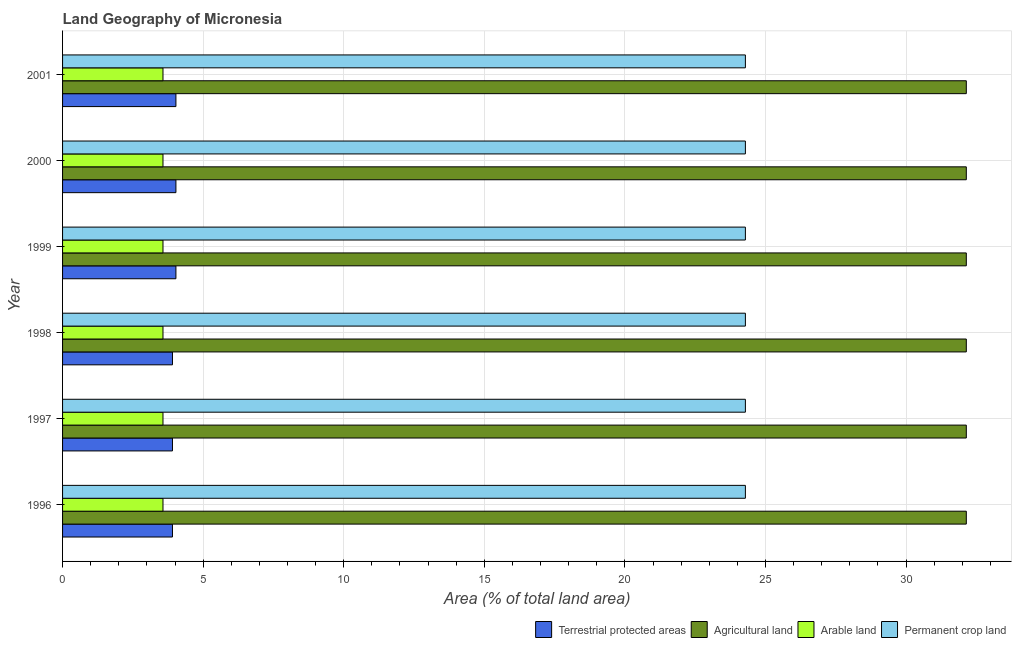How many groups of bars are there?
Ensure brevity in your answer.  6. Are the number of bars per tick equal to the number of legend labels?
Provide a short and direct response. Yes. What is the percentage of land under terrestrial protection in 1998?
Provide a succinct answer. 3.91. Across all years, what is the maximum percentage of area under agricultural land?
Give a very brief answer. 32.14. Across all years, what is the minimum percentage of area under permanent crop land?
Your answer should be compact. 24.29. In which year was the percentage of area under permanent crop land maximum?
Your answer should be very brief. 1996. In which year was the percentage of area under arable land minimum?
Your answer should be very brief. 1996. What is the total percentage of land under terrestrial protection in the graph?
Offer a terse response. 23.82. What is the difference between the percentage of area under arable land in 1997 and the percentage of area under agricultural land in 2001?
Your response must be concise. -28.57. What is the average percentage of area under agricultural land per year?
Your answer should be compact. 32.14. In the year 1999, what is the difference between the percentage of land under terrestrial protection and percentage of area under permanent crop land?
Provide a succinct answer. -20.25. In how many years, is the percentage of area under permanent crop land greater than 7 %?
Your answer should be very brief. 6. What is the ratio of the percentage of area under arable land in 1997 to that in 2000?
Make the answer very short. 1. Is the percentage of area under arable land in 1996 less than that in 1997?
Your answer should be very brief. No. What is the difference between the highest and the second highest percentage of area under arable land?
Give a very brief answer. 0. What is the difference between the highest and the lowest percentage of area under agricultural land?
Offer a terse response. 0. In how many years, is the percentage of land under terrestrial protection greater than the average percentage of land under terrestrial protection taken over all years?
Provide a succinct answer. 3. Is the sum of the percentage of land under terrestrial protection in 1997 and 2001 greater than the maximum percentage of area under permanent crop land across all years?
Ensure brevity in your answer.  No. What does the 1st bar from the top in 1998 represents?
Your answer should be compact. Permanent crop land. What does the 4th bar from the bottom in 1998 represents?
Offer a very short reply. Permanent crop land. Does the graph contain any zero values?
Ensure brevity in your answer.  No. Does the graph contain grids?
Offer a very short reply. Yes. Where does the legend appear in the graph?
Give a very brief answer. Bottom right. How many legend labels are there?
Make the answer very short. 4. How are the legend labels stacked?
Ensure brevity in your answer.  Horizontal. What is the title of the graph?
Make the answer very short. Land Geography of Micronesia. What is the label or title of the X-axis?
Give a very brief answer. Area (% of total land area). What is the Area (% of total land area) in Terrestrial protected areas in 1996?
Your answer should be compact. 3.91. What is the Area (% of total land area) in Agricultural land in 1996?
Give a very brief answer. 32.14. What is the Area (% of total land area) of Arable land in 1996?
Provide a short and direct response. 3.57. What is the Area (% of total land area) of Permanent crop land in 1996?
Ensure brevity in your answer.  24.29. What is the Area (% of total land area) of Terrestrial protected areas in 1997?
Provide a short and direct response. 3.91. What is the Area (% of total land area) of Agricultural land in 1997?
Offer a terse response. 32.14. What is the Area (% of total land area) of Arable land in 1997?
Keep it short and to the point. 3.57. What is the Area (% of total land area) of Permanent crop land in 1997?
Ensure brevity in your answer.  24.29. What is the Area (% of total land area) of Terrestrial protected areas in 1998?
Offer a terse response. 3.91. What is the Area (% of total land area) of Agricultural land in 1998?
Your answer should be compact. 32.14. What is the Area (% of total land area) of Arable land in 1998?
Your response must be concise. 3.57. What is the Area (% of total land area) of Permanent crop land in 1998?
Provide a succinct answer. 24.29. What is the Area (% of total land area) of Terrestrial protected areas in 1999?
Provide a succinct answer. 4.03. What is the Area (% of total land area) of Agricultural land in 1999?
Your answer should be compact. 32.14. What is the Area (% of total land area) of Arable land in 1999?
Keep it short and to the point. 3.57. What is the Area (% of total land area) in Permanent crop land in 1999?
Offer a very short reply. 24.29. What is the Area (% of total land area) in Terrestrial protected areas in 2000?
Keep it short and to the point. 4.03. What is the Area (% of total land area) of Agricultural land in 2000?
Offer a terse response. 32.14. What is the Area (% of total land area) of Arable land in 2000?
Give a very brief answer. 3.57. What is the Area (% of total land area) of Permanent crop land in 2000?
Offer a terse response. 24.29. What is the Area (% of total land area) of Terrestrial protected areas in 2001?
Your answer should be very brief. 4.03. What is the Area (% of total land area) of Agricultural land in 2001?
Give a very brief answer. 32.14. What is the Area (% of total land area) in Arable land in 2001?
Your answer should be very brief. 3.57. What is the Area (% of total land area) of Permanent crop land in 2001?
Offer a very short reply. 24.29. Across all years, what is the maximum Area (% of total land area) of Terrestrial protected areas?
Ensure brevity in your answer.  4.03. Across all years, what is the maximum Area (% of total land area) of Agricultural land?
Make the answer very short. 32.14. Across all years, what is the maximum Area (% of total land area) of Arable land?
Provide a short and direct response. 3.57. Across all years, what is the maximum Area (% of total land area) of Permanent crop land?
Your answer should be compact. 24.29. Across all years, what is the minimum Area (% of total land area) of Terrestrial protected areas?
Keep it short and to the point. 3.91. Across all years, what is the minimum Area (% of total land area) of Agricultural land?
Make the answer very short. 32.14. Across all years, what is the minimum Area (% of total land area) in Arable land?
Provide a short and direct response. 3.57. Across all years, what is the minimum Area (% of total land area) in Permanent crop land?
Provide a short and direct response. 24.29. What is the total Area (% of total land area) in Terrestrial protected areas in the graph?
Your response must be concise. 23.82. What is the total Area (% of total land area) in Agricultural land in the graph?
Your answer should be very brief. 192.86. What is the total Area (% of total land area) in Arable land in the graph?
Give a very brief answer. 21.43. What is the total Area (% of total land area) of Permanent crop land in the graph?
Keep it short and to the point. 145.71. What is the difference between the Area (% of total land area) of Agricultural land in 1996 and that in 1997?
Make the answer very short. 0. What is the difference between the Area (% of total land area) of Permanent crop land in 1996 and that in 1997?
Your response must be concise. 0. What is the difference between the Area (% of total land area) in Terrestrial protected areas in 1996 and that in 1998?
Give a very brief answer. 0. What is the difference between the Area (% of total land area) of Terrestrial protected areas in 1996 and that in 1999?
Ensure brevity in your answer.  -0.12. What is the difference between the Area (% of total land area) in Agricultural land in 1996 and that in 1999?
Provide a succinct answer. 0. What is the difference between the Area (% of total land area) of Arable land in 1996 and that in 1999?
Provide a succinct answer. 0. What is the difference between the Area (% of total land area) in Permanent crop land in 1996 and that in 1999?
Ensure brevity in your answer.  0. What is the difference between the Area (% of total land area) in Terrestrial protected areas in 1996 and that in 2000?
Offer a very short reply. -0.12. What is the difference between the Area (% of total land area) in Agricultural land in 1996 and that in 2000?
Your answer should be compact. 0. What is the difference between the Area (% of total land area) of Arable land in 1996 and that in 2000?
Keep it short and to the point. 0. What is the difference between the Area (% of total land area) in Terrestrial protected areas in 1996 and that in 2001?
Your answer should be compact. -0.12. What is the difference between the Area (% of total land area) of Permanent crop land in 1996 and that in 2001?
Your answer should be very brief. 0. What is the difference between the Area (% of total land area) in Terrestrial protected areas in 1997 and that in 1998?
Offer a terse response. 0. What is the difference between the Area (% of total land area) in Agricultural land in 1997 and that in 1998?
Offer a very short reply. 0. What is the difference between the Area (% of total land area) in Arable land in 1997 and that in 1998?
Your answer should be compact. 0. What is the difference between the Area (% of total land area) in Permanent crop land in 1997 and that in 1998?
Provide a succinct answer. 0. What is the difference between the Area (% of total land area) in Terrestrial protected areas in 1997 and that in 1999?
Your response must be concise. -0.12. What is the difference between the Area (% of total land area) in Arable land in 1997 and that in 1999?
Provide a succinct answer. 0. What is the difference between the Area (% of total land area) in Terrestrial protected areas in 1997 and that in 2000?
Offer a terse response. -0.12. What is the difference between the Area (% of total land area) in Agricultural land in 1997 and that in 2000?
Your answer should be very brief. 0. What is the difference between the Area (% of total land area) of Permanent crop land in 1997 and that in 2000?
Give a very brief answer. 0. What is the difference between the Area (% of total land area) of Terrestrial protected areas in 1997 and that in 2001?
Give a very brief answer. -0.12. What is the difference between the Area (% of total land area) in Arable land in 1997 and that in 2001?
Give a very brief answer. 0. What is the difference between the Area (% of total land area) of Permanent crop land in 1997 and that in 2001?
Make the answer very short. 0. What is the difference between the Area (% of total land area) of Terrestrial protected areas in 1998 and that in 1999?
Your response must be concise. -0.12. What is the difference between the Area (% of total land area) of Arable land in 1998 and that in 1999?
Your response must be concise. 0. What is the difference between the Area (% of total land area) of Permanent crop land in 1998 and that in 1999?
Offer a terse response. 0. What is the difference between the Area (% of total land area) of Terrestrial protected areas in 1998 and that in 2000?
Keep it short and to the point. -0.12. What is the difference between the Area (% of total land area) of Agricultural land in 1998 and that in 2000?
Give a very brief answer. 0. What is the difference between the Area (% of total land area) of Arable land in 1998 and that in 2000?
Your answer should be compact. 0. What is the difference between the Area (% of total land area) in Permanent crop land in 1998 and that in 2000?
Your answer should be very brief. 0. What is the difference between the Area (% of total land area) of Terrestrial protected areas in 1998 and that in 2001?
Your answer should be compact. -0.12. What is the difference between the Area (% of total land area) of Agricultural land in 1998 and that in 2001?
Your answer should be very brief. 0. What is the difference between the Area (% of total land area) in Terrestrial protected areas in 1999 and that in 2000?
Keep it short and to the point. 0. What is the difference between the Area (% of total land area) of Permanent crop land in 1999 and that in 2000?
Your answer should be very brief. 0. What is the difference between the Area (% of total land area) in Permanent crop land in 1999 and that in 2001?
Ensure brevity in your answer.  0. What is the difference between the Area (% of total land area) in Terrestrial protected areas in 2000 and that in 2001?
Provide a succinct answer. -0. What is the difference between the Area (% of total land area) in Arable land in 2000 and that in 2001?
Provide a short and direct response. 0. What is the difference between the Area (% of total land area) of Terrestrial protected areas in 1996 and the Area (% of total land area) of Agricultural land in 1997?
Give a very brief answer. -28.23. What is the difference between the Area (% of total land area) in Terrestrial protected areas in 1996 and the Area (% of total land area) in Arable land in 1997?
Ensure brevity in your answer.  0.34. What is the difference between the Area (% of total land area) in Terrestrial protected areas in 1996 and the Area (% of total land area) in Permanent crop land in 1997?
Provide a short and direct response. -20.38. What is the difference between the Area (% of total land area) in Agricultural land in 1996 and the Area (% of total land area) in Arable land in 1997?
Provide a short and direct response. 28.57. What is the difference between the Area (% of total land area) of Agricultural land in 1996 and the Area (% of total land area) of Permanent crop land in 1997?
Your response must be concise. 7.86. What is the difference between the Area (% of total land area) in Arable land in 1996 and the Area (% of total land area) in Permanent crop land in 1997?
Your answer should be very brief. -20.71. What is the difference between the Area (% of total land area) in Terrestrial protected areas in 1996 and the Area (% of total land area) in Agricultural land in 1998?
Offer a very short reply. -28.23. What is the difference between the Area (% of total land area) of Terrestrial protected areas in 1996 and the Area (% of total land area) of Arable land in 1998?
Keep it short and to the point. 0.34. What is the difference between the Area (% of total land area) of Terrestrial protected areas in 1996 and the Area (% of total land area) of Permanent crop land in 1998?
Make the answer very short. -20.38. What is the difference between the Area (% of total land area) in Agricultural land in 1996 and the Area (% of total land area) in Arable land in 1998?
Keep it short and to the point. 28.57. What is the difference between the Area (% of total land area) of Agricultural land in 1996 and the Area (% of total land area) of Permanent crop land in 1998?
Ensure brevity in your answer.  7.86. What is the difference between the Area (% of total land area) in Arable land in 1996 and the Area (% of total land area) in Permanent crop land in 1998?
Provide a succinct answer. -20.71. What is the difference between the Area (% of total land area) in Terrestrial protected areas in 1996 and the Area (% of total land area) in Agricultural land in 1999?
Keep it short and to the point. -28.23. What is the difference between the Area (% of total land area) of Terrestrial protected areas in 1996 and the Area (% of total land area) of Arable land in 1999?
Provide a short and direct response. 0.34. What is the difference between the Area (% of total land area) in Terrestrial protected areas in 1996 and the Area (% of total land area) in Permanent crop land in 1999?
Provide a short and direct response. -20.38. What is the difference between the Area (% of total land area) in Agricultural land in 1996 and the Area (% of total land area) in Arable land in 1999?
Provide a succinct answer. 28.57. What is the difference between the Area (% of total land area) of Agricultural land in 1996 and the Area (% of total land area) of Permanent crop land in 1999?
Your answer should be compact. 7.86. What is the difference between the Area (% of total land area) of Arable land in 1996 and the Area (% of total land area) of Permanent crop land in 1999?
Give a very brief answer. -20.71. What is the difference between the Area (% of total land area) in Terrestrial protected areas in 1996 and the Area (% of total land area) in Agricultural land in 2000?
Provide a succinct answer. -28.23. What is the difference between the Area (% of total land area) of Terrestrial protected areas in 1996 and the Area (% of total land area) of Arable land in 2000?
Your answer should be very brief. 0.34. What is the difference between the Area (% of total land area) in Terrestrial protected areas in 1996 and the Area (% of total land area) in Permanent crop land in 2000?
Offer a very short reply. -20.38. What is the difference between the Area (% of total land area) in Agricultural land in 1996 and the Area (% of total land area) in Arable land in 2000?
Keep it short and to the point. 28.57. What is the difference between the Area (% of total land area) in Agricultural land in 1996 and the Area (% of total land area) in Permanent crop land in 2000?
Your answer should be compact. 7.86. What is the difference between the Area (% of total land area) of Arable land in 1996 and the Area (% of total land area) of Permanent crop land in 2000?
Keep it short and to the point. -20.71. What is the difference between the Area (% of total land area) in Terrestrial protected areas in 1996 and the Area (% of total land area) in Agricultural land in 2001?
Your response must be concise. -28.23. What is the difference between the Area (% of total land area) in Terrestrial protected areas in 1996 and the Area (% of total land area) in Arable land in 2001?
Your answer should be very brief. 0.34. What is the difference between the Area (% of total land area) of Terrestrial protected areas in 1996 and the Area (% of total land area) of Permanent crop land in 2001?
Your answer should be very brief. -20.38. What is the difference between the Area (% of total land area) in Agricultural land in 1996 and the Area (% of total land area) in Arable land in 2001?
Your response must be concise. 28.57. What is the difference between the Area (% of total land area) in Agricultural land in 1996 and the Area (% of total land area) in Permanent crop land in 2001?
Give a very brief answer. 7.86. What is the difference between the Area (% of total land area) of Arable land in 1996 and the Area (% of total land area) of Permanent crop land in 2001?
Your response must be concise. -20.71. What is the difference between the Area (% of total land area) in Terrestrial protected areas in 1997 and the Area (% of total land area) in Agricultural land in 1998?
Provide a succinct answer. -28.23. What is the difference between the Area (% of total land area) of Terrestrial protected areas in 1997 and the Area (% of total land area) of Arable land in 1998?
Your answer should be compact. 0.34. What is the difference between the Area (% of total land area) in Terrestrial protected areas in 1997 and the Area (% of total land area) in Permanent crop land in 1998?
Keep it short and to the point. -20.38. What is the difference between the Area (% of total land area) of Agricultural land in 1997 and the Area (% of total land area) of Arable land in 1998?
Keep it short and to the point. 28.57. What is the difference between the Area (% of total land area) in Agricultural land in 1997 and the Area (% of total land area) in Permanent crop land in 1998?
Provide a succinct answer. 7.86. What is the difference between the Area (% of total land area) in Arable land in 1997 and the Area (% of total land area) in Permanent crop land in 1998?
Provide a short and direct response. -20.71. What is the difference between the Area (% of total land area) in Terrestrial protected areas in 1997 and the Area (% of total land area) in Agricultural land in 1999?
Ensure brevity in your answer.  -28.23. What is the difference between the Area (% of total land area) in Terrestrial protected areas in 1997 and the Area (% of total land area) in Arable land in 1999?
Offer a terse response. 0.34. What is the difference between the Area (% of total land area) of Terrestrial protected areas in 1997 and the Area (% of total land area) of Permanent crop land in 1999?
Provide a succinct answer. -20.38. What is the difference between the Area (% of total land area) of Agricultural land in 1997 and the Area (% of total land area) of Arable land in 1999?
Give a very brief answer. 28.57. What is the difference between the Area (% of total land area) in Agricultural land in 1997 and the Area (% of total land area) in Permanent crop land in 1999?
Your answer should be very brief. 7.86. What is the difference between the Area (% of total land area) in Arable land in 1997 and the Area (% of total land area) in Permanent crop land in 1999?
Keep it short and to the point. -20.71. What is the difference between the Area (% of total land area) of Terrestrial protected areas in 1997 and the Area (% of total land area) of Agricultural land in 2000?
Provide a succinct answer. -28.23. What is the difference between the Area (% of total land area) of Terrestrial protected areas in 1997 and the Area (% of total land area) of Arable land in 2000?
Your response must be concise. 0.34. What is the difference between the Area (% of total land area) of Terrestrial protected areas in 1997 and the Area (% of total land area) of Permanent crop land in 2000?
Your answer should be compact. -20.38. What is the difference between the Area (% of total land area) of Agricultural land in 1997 and the Area (% of total land area) of Arable land in 2000?
Your answer should be very brief. 28.57. What is the difference between the Area (% of total land area) in Agricultural land in 1997 and the Area (% of total land area) in Permanent crop land in 2000?
Provide a short and direct response. 7.86. What is the difference between the Area (% of total land area) of Arable land in 1997 and the Area (% of total land area) of Permanent crop land in 2000?
Ensure brevity in your answer.  -20.71. What is the difference between the Area (% of total land area) in Terrestrial protected areas in 1997 and the Area (% of total land area) in Agricultural land in 2001?
Offer a terse response. -28.23. What is the difference between the Area (% of total land area) in Terrestrial protected areas in 1997 and the Area (% of total land area) in Arable land in 2001?
Your answer should be very brief. 0.34. What is the difference between the Area (% of total land area) of Terrestrial protected areas in 1997 and the Area (% of total land area) of Permanent crop land in 2001?
Offer a terse response. -20.38. What is the difference between the Area (% of total land area) in Agricultural land in 1997 and the Area (% of total land area) in Arable land in 2001?
Give a very brief answer. 28.57. What is the difference between the Area (% of total land area) in Agricultural land in 1997 and the Area (% of total land area) in Permanent crop land in 2001?
Provide a short and direct response. 7.86. What is the difference between the Area (% of total land area) in Arable land in 1997 and the Area (% of total land area) in Permanent crop land in 2001?
Keep it short and to the point. -20.71. What is the difference between the Area (% of total land area) in Terrestrial protected areas in 1998 and the Area (% of total land area) in Agricultural land in 1999?
Your answer should be very brief. -28.23. What is the difference between the Area (% of total land area) in Terrestrial protected areas in 1998 and the Area (% of total land area) in Arable land in 1999?
Your response must be concise. 0.34. What is the difference between the Area (% of total land area) of Terrestrial protected areas in 1998 and the Area (% of total land area) of Permanent crop land in 1999?
Offer a terse response. -20.38. What is the difference between the Area (% of total land area) in Agricultural land in 1998 and the Area (% of total land area) in Arable land in 1999?
Keep it short and to the point. 28.57. What is the difference between the Area (% of total land area) of Agricultural land in 1998 and the Area (% of total land area) of Permanent crop land in 1999?
Give a very brief answer. 7.86. What is the difference between the Area (% of total land area) of Arable land in 1998 and the Area (% of total land area) of Permanent crop land in 1999?
Your answer should be very brief. -20.71. What is the difference between the Area (% of total land area) of Terrestrial protected areas in 1998 and the Area (% of total land area) of Agricultural land in 2000?
Offer a terse response. -28.23. What is the difference between the Area (% of total land area) of Terrestrial protected areas in 1998 and the Area (% of total land area) of Arable land in 2000?
Offer a terse response. 0.34. What is the difference between the Area (% of total land area) in Terrestrial protected areas in 1998 and the Area (% of total land area) in Permanent crop land in 2000?
Offer a very short reply. -20.38. What is the difference between the Area (% of total land area) in Agricultural land in 1998 and the Area (% of total land area) in Arable land in 2000?
Offer a terse response. 28.57. What is the difference between the Area (% of total land area) of Agricultural land in 1998 and the Area (% of total land area) of Permanent crop land in 2000?
Ensure brevity in your answer.  7.86. What is the difference between the Area (% of total land area) of Arable land in 1998 and the Area (% of total land area) of Permanent crop land in 2000?
Keep it short and to the point. -20.71. What is the difference between the Area (% of total land area) of Terrestrial protected areas in 1998 and the Area (% of total land area) of Agricultural land in 2001?
Make the answer very short. -28.23. What is the difference between the Area (% of total land area) of Terrestrial protected areas in 1998 and the Area (% of total land area) of Arable land in 2001?
Give a very brief answer. 0.34. What is the difference between the Area (% of total land area) in Terrestrial protected areas in 1998 and the Area (% of total land area) in Permanent crop land in 2001?
Provide a short and direct response. -20.38. What is the difference between the Area (% of total land area) in Agricultural land in 1998 and the Area (% of total land area) in Arable land in 2001?
Offer a very short reply. 28.57. What is the difference between the Area (% of total land area) in Agricultural land in 1998 and the Area (% of total land area) in Permanent crop land in 2001?
Offer a terse response. 7.86. What is the difference between the Area (% of total land area) in Arable land in 1998 and the Area (% of total land area) in Permanent crop land in 2001?
Ensure brevity in your answer.  -20.71. What is the difference between the Area (% of total land area) in Terrestrial protected areas in 1999 and the Area (% of total land area) in Agricultural land in 2000?
Your response must be concise. -28.11. What is the difference between the Area (% of total land area) in Terrestrial protected areas in 1999 and the Area (% of total land area) in Arable land in 2000?
Keep it short and to the point. 0.46. What is the difference between the Area (% of total land area) in Terrestrial protected areas in 1999 and the Area (% of total land area) in Permanent crop land in 2000?
Offer a terse response. -20.25. What is the difference between the Area (% of total land area) in Agricultural land in 1999 and the Area (% of total land area) in Arable land in 2000?
Offer a very short reply. 28.57. What is the difference between the Area (% of total land area) in Agricultural land in 1999 and the Area (% of total land area) in Permanent crop land in 2000?
Provide a short and direct response. 7.86. What is the difference between the Area (% of total land area) of Arable land in 1999 and the Area (% of total land area) of Permanent crop land in 2000?
Provide a succinct answer. -20.71. What is the difference between the Area (% of total land area) of Terrestrial protected areas in 1999 and the Area (% of total land area) of Agricultural land in 2001?
Offer a terse response. -28.11. What is the difference between the Area (% of total land area) of Terrestrial protected areas in 1999 and the Area (% of total land area) of Arable land in 2001?
Your answer should be compact. 0.46. What is the difference between the Area (% of total land area) in Terrestrial protected areas in 1999 and the Area (% of total land area) in Permanent crop land in 2001?
Your answer should be very brief. -20.25. What is the difference between the Area (% of total land area) in Agricultural land in 1999 and the Area (% of total land area) in Arable land in 2001?
Provide a short and direct response. 28.57. What is the difference between the Area (% of total land area) of Agricultural land in 1999 and the Area (% of total land area) of Permanent crop land in 2001?
Offer a terse response. 7.86. What is the difference between the Area (% of total land area) of Arable land in 1999 and the Area (% of total land area) of Permanent crop land in 2001?
Keep it short and to the point. -20.71. What is the difference between the Area (% of total land area) in Terrestrial protected areas in 2000 and the Area (% of total land area) in Agricultural land in 2001?
Provide a succinct answer. -28.11. What is the difference between the Area (% of total land area) of Terrestrial protected areas in 2000 and the Area (% of total land area) of Arable land in 2001?
Make the answer very short. 0.46. What is the difference between the Area (% of total land area) in Terrestrial protected areas in 2000 and the Area (% of total land area) in Permanent crop land in 2001?
Give a very brief answer. -20.25. What is the difference between the Area (% of total land area) of Agricultural land in 2000 and the Area (% of total land area) of Arable land in 2001?
Ensure brevity in your answer.  28.57. What is the difference between the Area (% of total land area) in Agricultural land in 2000 and the Area (% of total land area) in Permanent crop land in 2001?
Ensure brevity in your answer.  7.86. What is the difference between the Area (% of total land area) of Arable land in 2000 and the Area (% of total land area) of Permanent crop land in 2001?
Make the answer very short. -20.71. What is the average Area (% of total land area) of Terrestrial protected areas per year?
Provide a succinct answer. 3.97. What is the average Area (% of total land area) of Agricultural land per year?
Your answer should be compact. 32.14. What is the average Area (% of total land area) in Arable land per year?
Your response must be concise. 3.57. What is the average Area (% of total land area) of Permanent crop land per year?
Offer a very short reply. 24.29. In the year 1996, what is the difference between the Area (% of total land area) in Terrestrial protected areas and Area (% of total land area) in Agricultural land?
Your response must be concise. -28.23. In the year 1996, what is the difference between the Area (% of total land area) in Terrestrial protected areas and Area (% of total land area) in Arable land?
Your answer should be very brief. 0.34. In the year 1996, what is the difference between the Area (% of total land area) of Terrestrial protected areas and Area (% of total land area) of Permanent crop land?
Keep it short and to the point. -20.38. In the year 1996, what is the difference between the Area (% of total land area) of Agricultural land and Area (% of total land area) of Arable land?
Your answer should be compact. 28.57. In the year 1996, what is the difference between the Area (% of total land area) of Agricultural land and Area (% of total land area) of Permanent crop land?
Provide a short and direct response. 7.86. In the year 1996, what is the difference between the Area (% of total land area) of Arable land and Area (% of total land area) of Permanent crop land?
Offer a terse response. -20.71. In the year 1997, what is the difference between the Area (% of total land area) in Terrestrial protected areas and Area (% of total land area) in Agricultural land?
Keep it short and to the point. -28.23. In the year 1997, what is the difference between the Area (% of total land area) of Terrestrial protected areas and Area (% of total land area) of Arable land?
Ensure brevity in your answer.  0.34. In the year 1997, what is the difference between the Area (% of total land area) in Terrestrial protected areas and Area (% of total land area) in Permanent crop land?
Your response must be concise. -20.38. In the year 1997, what is the difference between the Area (% of total land area) of Agricultural land and Area (% of total land area) of Arable land?
Your answer should be very brief. 28.57. In the year 1997, what is the difference between the Area (% of total land area) of Agricultural land and Area (% of total land area) of Permanent crop land?
Keep it short and to the point. 7.86. In the year 1997, what is the difference between the Area (% of total land area) in Arable land and Area (% of total land area) in Permanent crop land?
Give a very brief answer. -20.71. In the year 1998, what is the difference between the Area (% of total land area) of Terrestrial protected areas and Area (% of total land area) of Agricultural land?
Your answer should be very brief. -28.23. In the year 1998, what is the difference between the Area (% of total land area) in Terrestrial protected areas and Area (% of total land area) in Arable land?
Provide a short and direct response. 0.34. In the year 1998, what is the difference between the Area (% of total land area) of Terrestrial protected areas and Area (% of total land area) of Permanent crop land?
Give a very brief answer. -20.38. In the year 1998, what is the difference between the Area (% of total land area) in Agricultural land and Area (% of total land area) in Arable land?
Your answer should be very brief. 28.57. In the year 1998, what is the difference between the Area (% of total land area) of Agricultural land and Area (% of total land area) of Permanent crop land?
Your answer should be compact. 7.86. In the year 1998, what is the difference between the Area (% of total land area) of Arable land and Area (% of total land area) of Permanent crop land?
Keep it short and to the point. -20.71. In the year 1999, what is the difference between the Area (% of total land area) in Terrestrial protected areas and Area (% of total land area) in Agricultural land?
Ensure brevity in your answer.  -28.11. In the year 1999, what is the difference between the Area (% of total land area) in Terrestrial protected areas and Area (% of total land area) in Arable land?
Offer a very short reply. 0.46. In the year 1999, what is the difference between the Area (% of total land area) of Terrestrial protected areas and Area (% of total land area) of Permanent crop land?
Give a very brief answer. -20.25. In the year 1999, what is the difference between the Area (% of total land area) of Agricultural land and Area (% of total land area) of Arable land?
Ensure brevity in your answer.  28.57. In the year 1999, what is the difference between the Area (% of total land area) in Agricultural land and Area (% of total land area) in Permanent crop land?
Your response must be concise. 7.86. In the year 1999, what is the difference between the Area (% of total land area) of Arable land and Area (% of total land area) of Permanent crop land?
Offer a very short reply. -20.71. In the year 2000, what is the difference between the Area (% of total land area) in Terrestrial protected areas and Area (% of total land area) in Agricultural land?
Your answer should be compact. -28.11. In the year 2000, what is the difference between the Area (% of total land area) of Terrestrial protected areas and Area (% of total land area) of Arable land?
Ensure brevity in your answer.  0.46. In the year 2000, what is the difference between the Area (% of total land area) in Terrestrial protected areas and Area (% of total land area) in Permanent crop land?
Give a very brief answer. -20.25. In the year 2000, what is the difference between the Area (% of total land area) of Agricultural land and Area (% of total land area) of Arable land?
Offer a very short reply. 28.57. In the year 2000, what is the difference between the Area (% of total land area) of Agricultural land and Area (% of total land area) of Permanent crop land?
Give a very brief answer. 7.86. In the year 2000, what is the difference between the Area (% of total land area) in Arable land and Area (% of total land area) in Permanent crop land?
Provide a succinct answer. -20.71. In the year 2001, what is the difference between the Area (% of total land area) of Terrestrial protected areas and Area (% of total land area) of Agricultural land?
Offer a terse response. -28.11. In the year 2001, what is the difference between the Area (% of total land area) of Terrestrial protected areas and Area (% of total land area) of Arable land?
Provide a succinct answer. 0.46. In the year 2001, what is the difference between the Area (% of total land area) of Terrestrial protected areas and Area (% of total land area) of Permanent crop land?
Offer a very short reply. -20.25. In the year 2001, what is the difference between the Area (% of total land area) of Agricultural land and Area (% of total land area) of Arable land?
Offer a terse response. 28.57. In the year 2001, what is the difference between the Area (% of total land area) of Agricultural land and Area (% of total land area) of Permanent crop land?
Provide a short and direct response. 7.86. In the year 2001, what is the difference between the Area (% of total land area) of Arable land and Area (% of total land area) of Permanent crop land?
Make the answer very short. -20.71. What is the ratio of the Area (% of total land area) of Terrestrial protected areas in 1996 to that in 1997?
Offer a terse response. 1. What is the ratio of the Area (% of total land area) of Arable land in 1996 to that in 1997?
Your answer should be compact. 1. What is the ratio of the Area (% of total land area) in Permanent crop land in 1996 to that in 1997?
Your response must be concise. 1. What is the ratio of the Area (% of total land area) in Arable land in 1996 to that in 1998?
Your response must be concise. 1. What is the ratio of the Area (% of total land area) in Terrestrial protected areas in 1996 to that in 1999?
Give a very brief answer. 0.97. What is the ratio of the Area (% of total land area) in Permanent crop land in 1996 to that in 1999?
Make the answer very short. 1. What is the ratio of the Area (% of total land area) of Terrestrial protected areas in 1996 to that in 2000?
Give a very brief answer. 0.97. What is the ratio of the Area (% of total land area) in Agricultural land in 1996 to that in 2000?
Offer a very short reply. 1. What is the ratio of the Area (% of total land area) in Terrestrial protected areas in 1996 to that in 2001?
Your answer should be very brief. 0.97. What is the ratio of the Area (% of total land area) in Agricultural land in 1996 to that in 2001?
Your answer should be very brief. 1. What is the ratio of the Area (% of total land area) in Arable land in 1996 to that in 2001?
Make the answer very short. 1. What is the ratio of the Area (% of total land area) of Permanent crop land in 1996 to that in 2001?
Provide a short and direct response. 1. What is the ratio of the Area (% of total land area) of Terrestrial protected areas in 1997 to that in 1999?
Make the answer very short. 0.97. What is the ratio of the Area (% of total land area) of Agricultural land in 1997 to that in 1999?
Your response must be concise. 1. What is the ratio of the Area (% of total land area) of Permanent crop land in 1997 to that in 1999?
Provide a short and direct response. 1. What is the ratio of the Area (% of total land area) of Terrestrial protected areas in 1997 to that in 2000?
Offer a very short reply. 0.97. What is the ratio of the Area (% of total land area) in Agricultural land in 1997 to that in 2000?
Provide a succinct answer. 1. What is the ratio of the Area (% of total land area) of Terrestrial protected areas in 1997 to that in 2001?
Give a very brief answer. 0.97. What is the ratio of the Area (% of total land area) in Arable land in 1997 to that in 2001?
Ensure brevity in your answer.  1. What is the ratio of the Area (% of total land area) of Terrestrial protected areas in 1998 to that in 1999?
Offer a terse response. 0.97. What is the ratio of the Area (% of total land area) of Agricultural land in 1998 to that in 1999?
Make the answer very short. 1. What is the ratio of the Area (% of total land area) in Arable land in 1998 to that in 1999?
Offer a terse response. 1. What is the ratio of the Area (% of total land area) of Terrestrial protected areas in 1998 to that in 2000?
Your answer should be compact. 0.97. What is the ratio of the Area (% of total land area) in Terrestrial protected areas in 1998 to that in 2001?
Make the answer very short. 0.97. What is the ratio of the Area (% of total land area) of Agricultural land in 1998 to that in 2001?
Your answer should be compact. 1. What is the ratio of the Area (% of total land area) of Arable land in 1998 to that in 2001?
Your answer should be very brief. 1. What is the ratio of the Area (% of total land area) of Permanent crop land in 1998 to that in 2001?
Make the answer very short. 1. What is the ratio of the Area (% of total land area) of Terrestrial protected areas in 1999 to that in 2000?
Your response must be concise. 1. What is the ratio of the Area (% of total land area) of Agricultural land in 1999 to that in 2000?
Keep it short and to the point. 1. What is the ratio of the Area (% of total land area) in Arable land in 1999 to that in 2000?
Offer a terse response. 1. What is the ratio of the Area (% of total land area) of Permanent crop land in 1999 to that in 2000?
Your answer should be very brief. 1. What is the ratio of the Area (% of total land area) in Terrestrial protected areas in 1999 to that in 2001?
Give a very brief answer. 1. What is the ratio of the Area (% of total land area) of Permanent crop land in 1999 to that in 2001?
Your answer should be very brief. 1. What is the ratio of the Area (% of total land area) in Agricultural land in 2000 to that in 2001?
Your answer should be very brief. 1. What is the ratio of the Area (% of total land area) in Arable land in 2000 to that in 2001?
Make the answer very short. 1. What is the ratio of the Area (% of total land area) of Permanent crop land in 2000 to that in 2001?
Keep it short and to the point. 1. What is the difference between the highest and the second highest Area (% of total land area) in Permanent crop land?
Ensure brevity in your answer.  0. What is the difference between the highest and the lowest Area (% of total land area) of Terrestrial protected areas?
Provide a short and direct response. 0.12. 